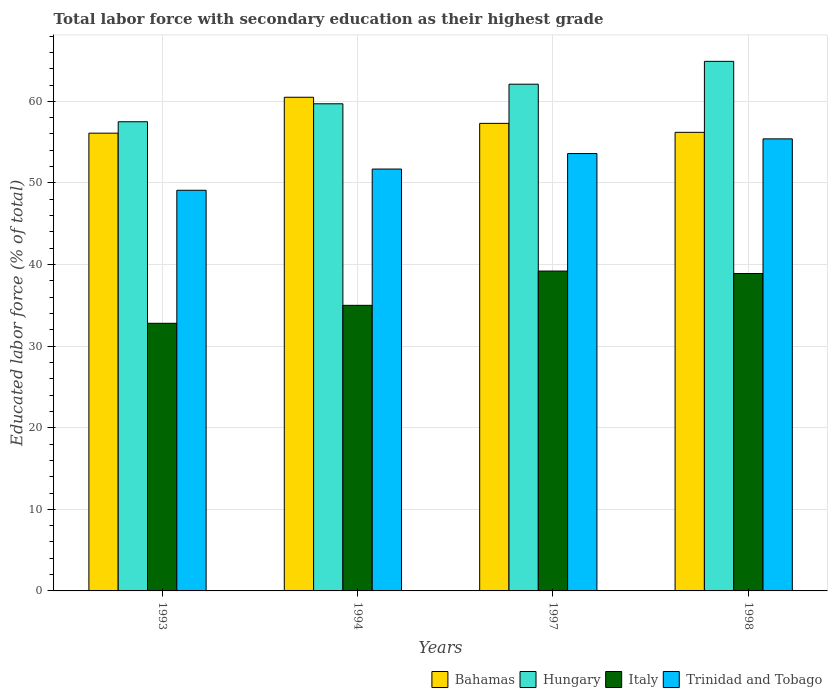How many different coloured bars are there?
Offer a terse response. 4. How many groups of bars are there?
Your response must be concise. 4. Are the number of bars on each tick of the X-axis equal?
Offer a terse response. Yes. How many bars are there on the 2nd tick from the right?
Your answer should be very brief. 4. What is the percentage of total labor force with primary education in Italy in 1998?
Offer a very short reply. 38.9. Across all years, what is the maximum percentage of total labor force with primary education in Italy?
Make the answer very short. 39.2. Across all years, what is the minimum percentage of total labor force with primary education in Trinidad and Tobago?
Give a very brief answer. 49.1. In which year was the percentage of total labor force with primary education in Trinidad and Tobago minimum?
Your answer should be very brief. 1993. What is the total percentage of total labor force with primary education in Italy in the graph?
Keep it short and to the point. 145.9. What is the difference between the percentage of total labor force with primary education in Bahamas in 1993 and that in 1998?
Your answer should be compact. -0.1. What is the difference between the percentage of total labor force with primary education in Trinidad and Tobago in 1997 and the percentage of total labor force with primary education in Hungary in 1994?
Make the answer very short. -6.1. What is the average percentage of total labor force with primary education in Hungary per year?
Make the answer very short. 61.05. In the year 1998, what is the difference between the percentage of total labor force with primary education in Italy and percentage of total labor force with primary education in Trinidad and Tobago?
Your answer should be very brief. -16.5. In how many years, is the percentage of total labor force with primary education in Italy greater than 38 %?
Make the answer very short. 2. What is the ratio of the percentage of total labor force with primary education in Hungary in 1993 to that in 1994?
Offer a terse response. 0.96. Is the difference between the percentage of total labor force with primary education in Italy in 1994 and 1997 greater than the difference between the percentage of total labor force with primary education in Trinidad and Tobago in 1994 and 1997?
Ensure brevity in your answer.  No. What is the difference between the highest and the second highest percentage of total labor force with primary education in Italy?
Offer a very short reply. 0.3. What is the difference between the highest and the lowest percentage of total labor force with primary education in Trinidad and Tobago?
Provide a succinct answer. 6.3. In how many years, is the percentage of total labor force with primary education in Hungary greater than the average percentage of total labor force with primary education in Hungary taken over all years?
Keep it short and to the point. 2. What does the 4th bar from the left in 1994 represents?
Make the answer very short. Trinidad and Tobago. What does the 3rd bar from the right in 1993 represents?
Your response must be concise. Hungary. How many bars are there?
Offer a terse response. 16. How many years are there in the graph?
Keep it short and to the point. 4. What is the difference between two consecutive major ticks on the Y-axis?
Your answer should be very brief. 10. Where does the legend appear in the graph?
Your answer should be compact. Bottom right. How many legend labels are there?
Provide a short and direct response. 4. How are the legend labels stacked?
Your answer should be compact. Horizontal. What is the title of the graph?
Make the answer very short. Total labor force with secondary education as their highest grade. Does "Qatar" appear as one of the legend labels in the graph?
Provide a succinct answer. No. What is the label or title of the X-axis?
Keep it short and to the point. Years. What is the label or title of the Y-axis?
Keep it short and to the point. Educated labor force (% of total). What is the Educated labor force (% of total) in Bahamas in 1993?
Offer a terse response. 56.1. What is the Educated labor force (% of total) of Hungary in 1993?
Offer a terse response. 57.5. What is the Educated labor force (% of total) of Italy in 1993?
Your answer should be very brief. 32.8. What is the Educated labor force (% of total) of Trinidad and Tobago in 1993?
Ensure brevity in your answer.  49.1. What is the Educated labor force (% of total) of Bahamas in 1994?
Provide a succinct answer. 60.5. What is the Educated labor force (% of total) of Hungary in 1994?
Offer a very short reply. 59.7. What is the Educated labor force (% of total) of Italy in 1994?
Ensure brevity in your answer.  35. What is the Educated labor force (% of total) in Trinidad and Tobago in 1994?
Make the answer very short. 51.7. What is the Educated labor force (% of total) of Bahamas in 1997?
Your response must be concise. 57.3. What is the Educated labor force (% of total) of Hungary in 1997?
Provide a short and direct response. 62.1. What is the Educated labor force (% of total) of Italy in 1997?
Offer a very short reply. 39.2. What is the Educated labor force (% of total) of Trinidad and Tobago in 1997?
Your response must be concise. 53.6. What is the Educated labor force (% of total) in Bahamas in 1998?
Your answer should be very brief. 56.2. What is the Educated labor force (% of total) of Hungary in 1998?
Offer a very short reply. 64.9. What is the Educated labor force (% of total) in Italy in 1998?
Offer a terse response. 38.9. What is the Educated labor force (% of total) in Trinidad and Tobago in 1998?
Your answer should be very brief. 55.4. Across all years, what is the maximum Educated labor force (% of total) of Bahamas?
Ensure brevity in your answer.  60.5. Across all years, what is the maximum Educated labor force (% of total) in Hungary?
Keep it short and to the point. 64.9. Across all years, what is the maximum Educated labor force (% of total) in Italy?
Your answer should be compact. 39.2. Across all years, what is the maximum Educated labor force (% of total) of Trinidad and Tobago?
Keep it short and to the point. 55.4. Across all years, what is the minimum Educated labor force (% of total) in Bahamas?
Your response must be concise. 56.1. Across all years, what is the minimum Educated labor force (% of total) of Hungary?
Give a very brief answer. 57.5. Across all years, what is the minimum Educated labor force (% of total) of Italy?
Your answer should be compact. 32.8. Across all years, what is the minimum Educated labor force (% of total) of Trinidad and Tobago?
Keep it short and to the point. 49.1. What is the total Educated labor force (% of total) of Bahamas in the graph?
Your answer should be compact. 230.1. What is the total Educated labor force (% of total) in Hungary in the graph?
Keep it short and to the point. 244.2. What is the total Educated labor force (% of total) in Italy in the graph?
Offer a terse response. 145.9. What is the total Educated labor force (% of total) in Trinidad and Tobago in the graph?
Give a very brief answer. 209.8. What is the difference between the Educated labor force (% of total) in Trinidad and Tobago in 1993 and that in 1997?
Make the answer very short. -4.5. What is the difference between the Educated labor force (% of total) in Hungary in 1993 and that in 1998?
Offer a terse response. -7.4. What is the difference between the Educated labor force (% of total) of Trinidad and Tobago in 1993 and that in 1998?
Provide a succinct answer. -6.3. What is the difference between the Educated labor force (% of total) of Bahamas in 1994 and that in 1997?
Provide a short and direct response. 3.2. What is the difference between the Educated labor force (% of total) of Italy in 1994 and that in 1997?
Your answer should be very brief. -4.2. What is the difference between the Educated labor force (% of total) of Bahamas in 1994 and that in 1998?
Make the answer very short. 4.3. What is the difference between the Educated labor force (% of total) in Hungary in 1994 and that in 1998?
Offer a very short reply. -5.2. What is the difference between the Educated labor force (% of total) of Trinidad and Tobago in 1994 and that in 1998?
Your response must be concise. -3.7. What is the difference between the Educated labor force (% of total) in Italy in 1997 and that in 1998?
Offer a very short reply. 0.3. What is the difference between the Educated labor force (% of total) of Trinidad and Tobago in 1997 and that in 1998?
Your answer should be very brief. -1.8. What is the difference between the Educated labor force (% of total) of Bahamas in 1993 and the Educated labor force (% of total) of Hungary in 1994?
Provide a succinct answer. -3.6. What is the difference between the Educated labor force (% of total) in Bahamas in 1993 and the Educated labor force (% of total) in Italy in 1994?
Your response must be concise. 21.1. What is the difference between the Educated labor force (% of total) in Hungary in 1993 and the Educated labor force (% of total) in Italy in 1994?
Keep it short and to the point. 22.5. What is the difference between the Educated labor force (% of total) in Hungary in 1993 and the Educated labor force (% of total) in Trinidad and Tobago in 1994?
Provide a succinct answer. 5.8. What is the difference between the Educated labor force (% of total) in Italy in 1993 and the Educated labor force (% of total) in Trinidad and Tobago in 1994?
Your answer should be very brief. -18.9. What is the difference between the Educated labor force (% of total) of Bahamas in 1993 and the Educated labor force (% of total) of Trinidad and Tobago in 1997?
Your answer should be very brief. 2.5. What is the difference between the Educated labor force (% of total) of Hungary in 1993 and the Educated labor force (% of total) of Trinidad and Tobago in 1997?
Your answer should be very brief. 3.9. What is the difference between the Educated labor force (% of total) in Italy in 1993 and the Educated labor force (% of total) in Trinidad and Tobago in 1997?
Provide a short and direct response. -20.8. What is the difference between the Educated labor force (% of total) in Bahamas in 1993 and the Educated labor force (% of total) in Hungary in 1998?
Ensure brevity in your answer.  -8.8. What is the difference between the Educated labor force (% of total) in Bahamas in 1993 and the Educated labor force (% of total) in Italy in 1998?
Your response must be concise. 17.2. What is the difference between the Educated labor force (% of total) of Bahamas in 1993 and the Educated labor force (% of total) of Trinidad and Tobago in 1998?
Make the answer very short. 0.7. What is the difference between the Educated labor force (% of total) in Hungary in 1993 and the Educated labor force (% of total) in Italy in 1998?
Offer a terse response. 18.6. What is the difference between the Educated labor force (% of total) of Italy in 1993 and the Educated labor force (% of total) of Trinidad and Tobago in 1998?
Provide a short and direct response. -22.6. What is the difference between the Educated labor force (% of total) in Bahamas in 1994 and the Educated labor force (% of total) in Hungary in 1997?
Offer a terse response. -1.6. What is the difference between the Educated labor force (% of total) in Bahamas in 1994 and the Educated labor force (% of total) in Italy in 1997?
Make the answer very short. 21.3. What is the difference between the Educated labor force (% of total) of Italy in 1994 and the Educated labor force (% of total) of Trinidad and Tobago in 1997?
Your answer should be compact. -18.6. What is the difference between the Educated labor force (% of total) in Bahamas in 1994 and the Educated labor force (% of total) in Italy in 1998?
Offer a terse response. 21.6. What is the difference between the Educated labor force (% of total) of Bahamas in 1994 and the Educated labor force (% of total) of Trinidad and Tobago in 1998?
Offer a terse response. 5.1. What is the difference between the Educated labor force (% of total) of Hungary in 1994 and the Educated labor force (% of total) of Italy in 1998?
Provide a succinct answer. 20.8. What is the difference between the Educated labor force (% of total) of Hungary in 1994 and the Educated labor force (% of total) of Trinidad and Tobago in 1998?
Provide a short and direct response. 4.3. What is the difference between the Educated labor force (% of total) of Italy in 1994 and the Educated labor force (% of total) of Trinidad and Tobago in 1998?
Your response must be concise. -20.4. What is the difference between the Educated labor force (% of total) in Bahamas in 1997 and the Educated labor force (% of total) in Hungary in 1998?
Provide a succinct answer. -7.6. What is the difference between the Educated labor force (% of total) of Bahamas in 1997 and the Educated labor force (% of total) of Italy in 1998?
Offer a very short reply. 18.4. What is the difference between the Educated labor force (% of total) in Bahamas in 1997 and the Educated labor force (% of total) in Trinidad and Tobago in 1998?
Your answer should be compact. 1.9. What is the difference between the Educated labor force (% of total) of Hungary in 1997 and the Educated labor force (% of total) of Italy in 1998?
Ensure brevity in your answer.  23.2. What is the difference between the Educated labor force (% of total) of Italy in 1997 and the Educated labor force (% of total) of Trinidad and Tobago in 1998?
Give a very brief answer. -16.2. What is the average Educated labor force (% of total) in Bahamas per year?
Offer a terse response. 57.52. What is the average Educated labor force (% of total) of Hungary per year?
Offer a very short reply. 61.05. What is the average Educated labor force (% of total) in Italy per year?
Your answer should be compact. 36.48. What is the average Educated labor force (% of total) of Trinidad and Tobago per year?
Give a very brief answer. 52.45. In the year 1993, what is the difference between the Educated labor force (% of total) in Bahamas and Educated labor force (% of total) in Hungary?
Provide a short and direct response. -1.4. In the year 1993, what is the difference between the Educated labor force (% of total) in Bahamas and Educated labor force (% of total) in Italy?
Make the answer very short. 23.3. In the year 1993, what is the difference between the Educated labor force (% of total) of Hungary and Educated labor force (% of total) of Italy?
Offer a terse response. 24.7. In the year 1993, what is the difference between the Educated labor force (% of total) of Hungary and Educated labor force (% of total) of Trinidad and Tobago?
Offer a very short reply. 8.4. In the year 1993, what is the difference between the Educated labor force (% of total) in Italy and Educated labor force (% of total) in Trinidad and Tobago?
Offer a terse response. -16.3. In the year 1994, what is the difference between the Educated labor force (% of total) of Bahamas and Educated labor force (% of total) of Hungary?
Ensure brevity in your answer.  0.8. In the year 1994, what is the difference between the Educated labor force (% of total) of Hungary and Educated labor force (% of total) of Italy?
Provide a succinct answer. 24.7. In the year 1994, what is the difference between the Educated labor force (% of total) in Hungary and Educated labor force (% of total) in Trinidad and Tobago?
Make the answer very short. 8. In the year 1994, what is the difference between the Educated labor force (% of total) in Italy and Educated labor force (% of total) in Trinidad and Tobago?
Offer a terse response. -16.7. In the year 1997, what is the difference between the Educated labor force (% of total) in Bahamas and Educated labor force (% of total) in Italy?
Ensure brevity in your answer.  18.1. In the year 1997, what is the difference between the Educated labor force (% of total) in Hungary and Educated labor force (% of total) in Italy?
Give a very brief answer. 22.9. In the year 1997, what is the difference between the Educated labor force (% of total) in Italy and Educated labor force (% of total) in Trinidad and Tobago?
Offer a very short reply. -14.4. In the year 1998, what is the difference between the Educated labor force (% of total) in Bahamas and Educated labor force (% of total) in Hungary?
Make the answer very short. -8.7. In the year 1998, what is the difference between the Educated labor force (% of total) of Bahamas and Educated labor force (% of total) of Italy?
Your answer should be very brief. 17.3. In the year 1998, what is the difference between the Educated labor force (% of total) in Italy and Educated labor force (% of total) in Trinidad and Tobago?
Ensure brevity in your answer.  -16.5. What is the ratio of the Educated labor force (% of total) in Bahamas in 1993 to that in 1994?
Your answer should be compact. 0.93. What is the ratio of the Educated labor force (% of total) of Hungary in 1993 to that in 1994?
Offer a terse response. 0.96. What is the ratio of the Educated labor force (% of total) of Italy in 1993 to that in 1994?
Your answer should be compact. 0.94. What is the ratio of the Educated labor force (% of total) of Trinidad and Tobago in 1993 to that in 1994?
Your answer should be very brief. 0.95. What is the ratio of the Educated labor force (% of total) of Bahamas in 1993 to that in 1997?
Give a very brief answer. 0.98. What is the ratio of the Educated labor force (% of total) of Hungary in 1993 to that in 1997?
Keep it short and to the point. 0.93. What is the ratio of the Educated labor force (% of total) of Italy in 1993 to that in 1997?
Give a very brief answer. 0.84. What is the ratio of the Educated labor force (% of total) in Trinidad and Tobago in 1993 to that in 1997?
Keep it short and to the point. 0.92. What is the ratio of the Educated labor force (% of total) in Hungary in 1993 to that in 1998?
Ensure brevity in your answer.  0.89. What is the ratio of the Educated labor force (% of total) of Italy in 1993 to that in 1998?
Your answer should be compact. 0.84. What is the ratio of the Educated labor force (% of total) of Trinidad and Tobago in 1993 to that in 1998?
Keep it short and to the point. 0.89. What is the ratio of the Educated labor force (% of total) of Bahamas in 1994 to that in 1997?
Offer a terse response. 1.06. What is the ratio of the Educated labor force (% of total) in Hungary in 1994 to that in 1997?
Provide a short and direct response. 0.96. What is the ratio of the Educated labor force (% of total) of Italy in 1994 to that in 1997?
Offer a terse response. 0.89. What is the ratio of the Educated labor force (% of total) of Trinidad and Tobago in 1994 to that in 1997?
Offer a very short reply. 0.96. What is the ratio of the Educated labor force (% of total) of Bahamas in 1994 to that in 1998?
Your answer should be very brief. 1.08. What is the ratio of the Educated labor force (% of total) in Hungary in 1994 to that in 1998?
Your response must be concise. 0.92. What is the ratio of the Educated labor force (% of total) in Italy in 1994 to that in 1998?
Provide a short and direct response. 0.9. What is the ratio of the Educated labor force (% of total) of Trinidad and Tobago in 1994 to that in 1998?
Make the answer very short. 0.93. What is the ratio of the Educated labor force (% of total) in Bahamas in 1997 to that in 1998?
Provide a succinct answer. 1.02. What is the ratio of the Educated labor force (% of total) in Hungary in 1997 to that in 1998?
Give a very brief answer. 0.96. What is the ratio of the Educated labor force (% of total) of Italy in 1997 to that in 1998?
Provide a short and direct response. 1.01. What is the ratio of the Educated labor force (% of total) in Trinidad and Tobago in 1997 to that in 1998?
Your answer should be very brief. 0.97. What is the difference between the highest and the second highest Educated labor force (% of total) in Bahamas?
Give a very brief answer. 3.2. What is the difference between the highest and the second highest Educated labor force (% of total) in Italy?
Your response must be concise. 0.3. What is the difference between the highest and the second highest Educated labor force (% of total) in Trinidad and Tobago?
Give a very brief answer. 1.8. What is the difference between the highest and the lowest Educated labor force (% of total) of Bahamas?
Give a very brief answer. 4.4. What is the difference between the highest and the lowest Educated labor force (% of total) in Italy?
Give a very brief answer. 6.4. 